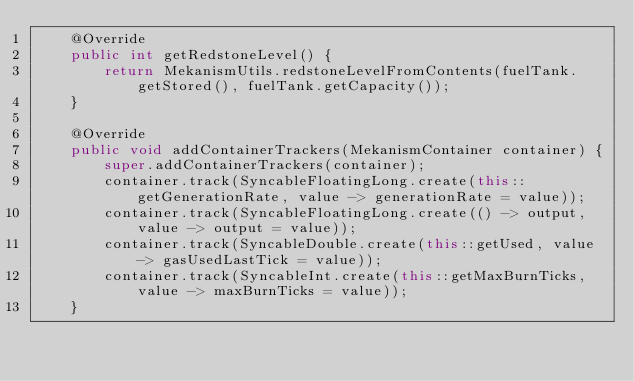<code> <loc_0><loc_0><loc_500><loc_500><_Java_>    @Override
    public int getRedstoneLevel() {
        return MekanismUtils.redstoneLevelFromContents(fuelTank.getStored(), fuelTank.getCapacity());
    }

    @Override
    public void addContainerTrackers(MekanismContainer container) {
        super.addContainerTrackers(container);
        container.track(SyncableFloatingLong.create(this::getGenerationRate, value -> generationRate = value));
        container.track(SyncableFloatingLong.create(() -> output, value -> output = value));
        container.track(SyncableDouble.create(this::getUsed, value -> gasUsedLastTick = value));
        container.track(SyncableInt.create(this::getMaxBurnTicks, value -> maxBurnTicks = value));
    }
</code> 